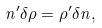Convert formula to latex. <formula><loc_0><loc_0><loc_500><loc_500>n ^ { \prime } \delta \rho = \rho ^ { \prime } \delta n ,</formula> 